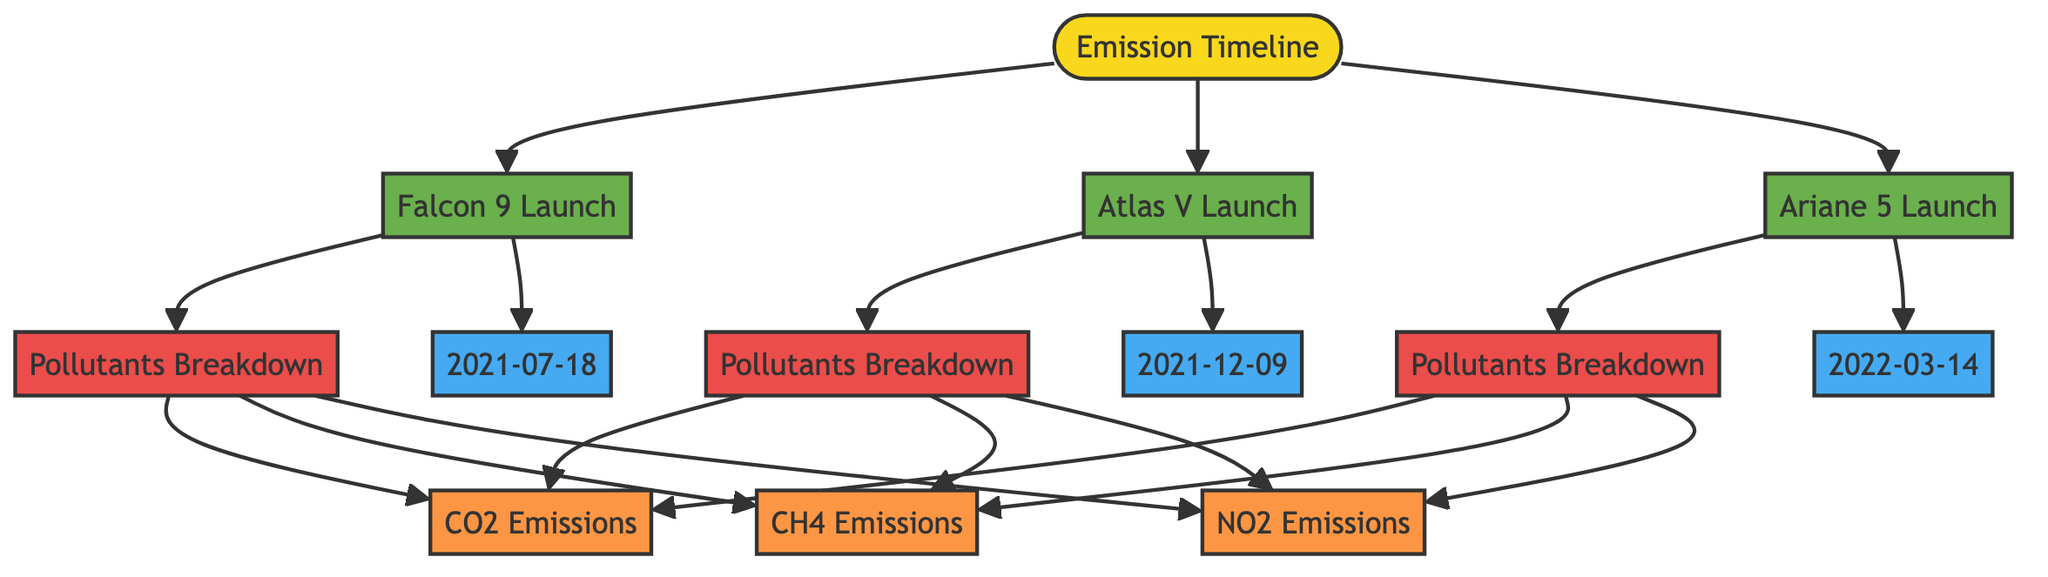what are the launch dates for the three rocket launches? From the diagram, the dates for the launches are displayed next to each launch node. The Falcon 9 Launch has the date 2021-07-18, Atlas V Launch has 2021-12-09, and Ariane 5 Launch has 2022-03-14.
Answer: 2021-07-18, 2021-12-09, 2022-03-14 how many pollutants are listed for each launch? In the diagram, there's a breakdown of pollutants for each launch. Each launch has three pollutants listed: CO2 Emissions, CH4 Emissions, and NO2 Emissions. Thus, each launch has three pollutants.
Answer: three which rocket launch has the highest emissions timeline? The diagram shows a direct link from each rocket launch to the emissions timeline. Since the diagram does not indicate any relative scale of emissions, we must infer based on the presence of launches alone. Therefore, each launch can be seen as equal on the timeline. Except, the emissions details would be further investigated in the respective pollutants breakdown.
Answer: equal what are the types of emissions categorized in the diagram? The diagram categorizes emissions into three types: CO2 Emissions, CH4 Emissions, and NO2 Emissions. Each of these can be seen branching off from the pollutants breakdown for each launch.
Answer: CO2, CH4, NO2 how many total launch nodes are represented in the diagram? The diagram has three launch nodes, represented as Falcon 9 Launch, Atlas V Launch, and Ariane 5 Launch. Counting these nodes gives us a total of three.
Answer: three 